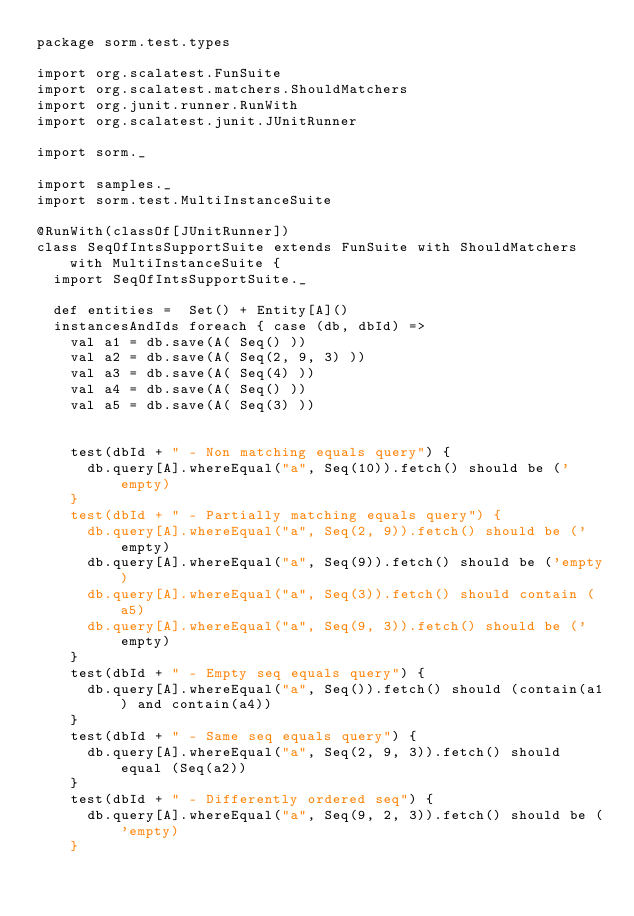<code> <loc_0><loc_0><loc_500><loc_500><_Scala_>package sorm.test.types

import org.scalatest.FunSuite
import org.scalatest.matchers.ShouldMatchers
import org.junit.runner.RunWith
import org.scalatest.junit.JUnitRunner

import sorm._

import samples._
import sorm.test.MultiInstanceSuite

@RunWith(classOf[JUnitRunner])
class SeqOfIntsSupportSuite extends FunSuite with ShouldMatchers with MultiInstanceSuite {
  import SeqOfIntsSupportSuite._

  def entities =  Set() + Entity[A]()
  instancesAndIds foreach { case (db, dbId) =>
    val a1 = db.save(A( Seq() ))
    val a2 = db.save(A( Seq(2, 9, 3) ))
    val a3 = db.save(A( Seq(4) ))
    val a4 = db.save(A( Seq() ))
    val a5 = db.save(A( Seq(3) ))


    test(dbId + " - Non matching equals query") {
      db.query[A].whereEqual("a", Seq(10)).fetch() should be ('empty)
    }
    test(dbId + " - Partially matching equals query") {
      db.query[A].whereEqual("a", Seq(2, 9)).fetch() should be ('empty)
      db.query[A].whereEqual("a", Seq(9)).fetch() should be ('empty)
      db.query[A].whereEqual("a", Seq(3)).fetch() should contain (a5)
      db.query[A].whereEqual("a", Seq(9, 3)).fetch() should be ('empty)
    }
    test(dbId + " - Empty seq equals query") {
      db.query[A].whereEqual("a", Seq()).fetch() should (contain(a1) and contain(a4))
    }
    test(dbId + " - Same seq equals query") {
      db.query[A].whereEqual("a", Seq(2, 9, 3)).fetch() should equal (Seq(a2))
    }
    test(dbId + " - Differently ordered seq") {
      db.query[A].whereEqual("a", Seq(9, 2, 3)).fetch() should be ('empty)
    }</code> 